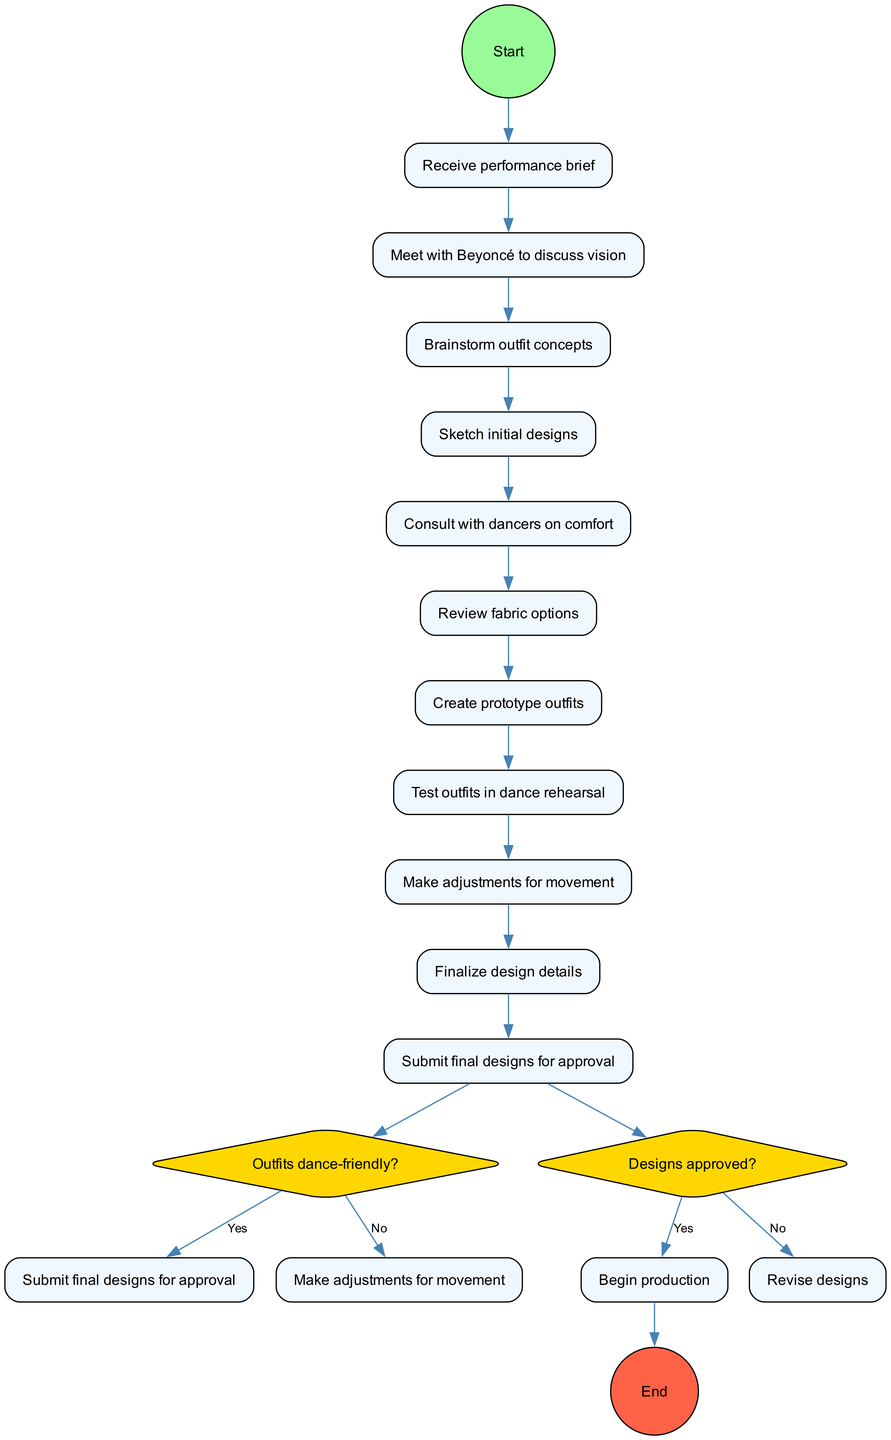What is the first activity in the diagram? The initial node labeled "Receive performance brief" indicates that this is the first step in the process, serving as the starting point for the activity flow.
Answer: Receive performance brief How many decision nodes are in the diagram? There are two decision nodes, as indicated in the data. Each node presents a question that influences the subsequent steps in the flow.
Answer: 2 What do you do after reviewing fabric options? After reviewing fabric options, the next step is to create prototype outfits, according to the sequential flow of activities in the diagram.
Answer: Create prototype outfits What question is asked after testing outfits in dance rehearsal? The diagram branches from the activity of testing outfits to a decision node where the question "Outfits dance-friendly?" is asked to evaluate the comfort of the outfits.
Answer: Outfits dance-friendly? If the final designs are not approved, what is the next step? If the designs are not approved, the flow goes to "Revise designs," which is the action to take when approval is denied, as stated in the decision node's 'no' option.
Answer: Revise designs What activity follows "Sketch initial designs"? The activity that directly follows "Sketch initial designs" in the flow is "Consult with dancers on comfort," indicating a focus on usability before moving forward.
Answer: Consult with dancers on comfort What happens if the outfits are dance-friendly? If the outfits are determined to be dance-friendly, the process moves forward to "Submit final designs for approval," showing that positive validation leads to progression in the workflow.
Answer: Submit final designs for approval What is the final node in the diagram? The last node in the flow is labeled "Begin production," marking the completion of the process after the approval of the designs.
Answer: Begin production 